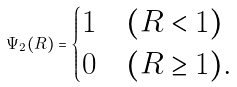Convert formula to latex. <formula><loc_0><loc_0><loc_500><loc_500>\Psi _ { 2 } ( R ) = \begin{cases} 1 & ( R < 1 ) \\ 0 & ( R \geq 1 ) . \end{cases}</formula> 